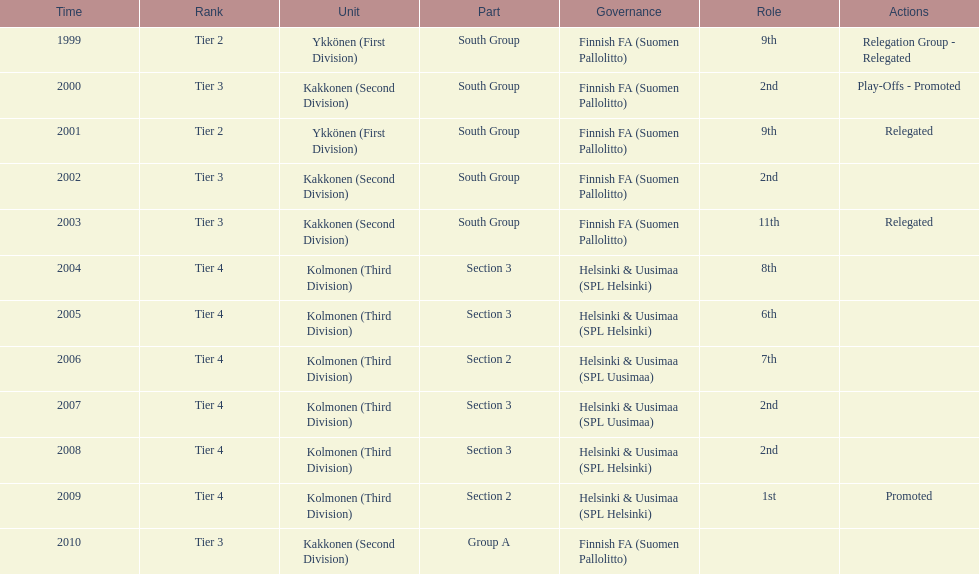Which administration has the least amount of division? Helsinki & Uusimaa (SPL Helsinki). 